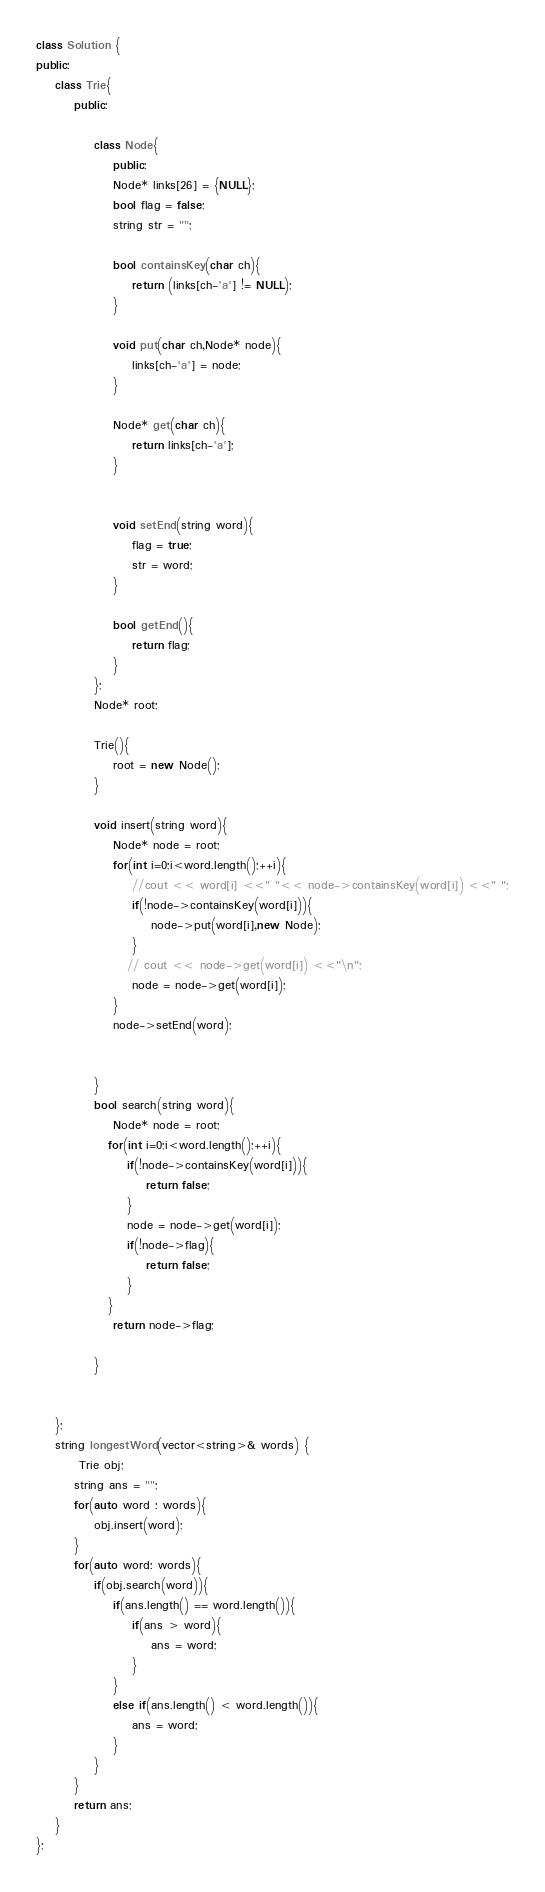<code> <loc_0><loc_0><loc_500><loc_500><_C++_>class Solution {
public:
    class Trie{
        public:
            
            class Node{
                public:
                Node* links[26] = {NULL};
                bool flag = false;
                string str = "";
                
                bool containsKey(char ch){
                    return (links[ch-'a'] != NULL);
                }
                
                void put(char ch,Node* node){
                    links[ch-'a'] = node;
                }
                
                Node* get(char ch){
                    return links[ch-'a'];
                }
                
                
                void setEnd(string word){
                    flag = true;
                    str = word;
                }
                
                bool getEnd(){
                    return flag;
                }
            };
            Node* root;
            
            Trie(){
                root = new Node();
            }
            
            void insert(string word){
                Node* node = root;
                for(int i=0;i<word.length();++i){
                    //cout << word[i] <<" "<< node->containsKey(word[i]) <<" ";
                    if(!node->containsKey(word[i])){
                        node->put(word[i],new Node);
                    }
                   // cout << node->get(word[i]) <<"\n";
                    node = node->get(word[i]);
                }
                node->setEnd(word);
                
                
            }
            bool search(string word){   
                Node* node = root;
               for(int i=0;i<word.length();++i){
                   if(!node->containsKey(word[i])){
                       return false;
                   }
                   node = node->get(word[i]);
                   if(!node->flag){
                       return false;
                   }
               }
                return node->flag;
                
            }
            
        
    };
    string longestWord(vector<string>& words) {
         Trie obj;
        string ans = "";
        for(auto word : words){
            obj.insert(word);   
        }
        for(auto word: words){
            if(obj.search(word)){
                if(ans.length() == word.length()){
                    if(ans > word){
                        ans = word;
                    }
                }
                else if(ans.length() < word.length()){
                    ans = word;
                }
            }
        }
        return ans;
    }
};</code> 